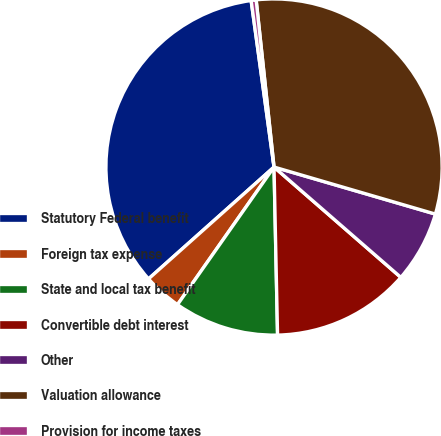<chart> <loc_0><loc_0><loc_500><loc_500><pie_chart><fcel>Statutory Federal benefit<fcel>Foreign tax expense<fcel>State and local tax benefit<fcel>Convertible debt interest<fcel>Other<fcel>Valuation allowance<fcel>Provision for income taxes<nl><fcel>34.41%<fcel>3.68%<fcel>10.07%<fcel>13.27%<fcel>6.88%<fcel>31.21%<fcel>0.48%<nl></chart> 